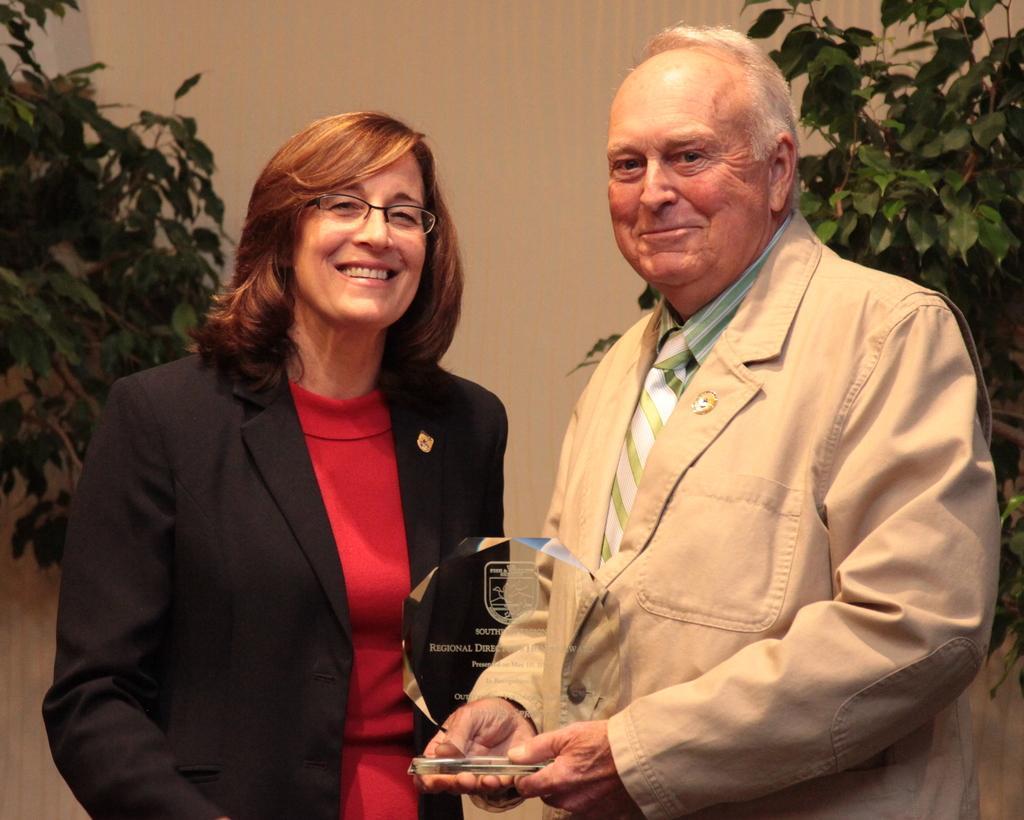In one or two sentences, can you explain what this image depicts? In this image I can see a woman and a man are standing and smiling. I can see the man is holding a momentum award in his hand. In the background I can see the cream colored surface and few trees which are green in color. 